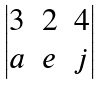<formula> <loc_0><loc_0><loc_500><loc_500>\begin{vmatrix} 3 & 2 & 4 \\ a & e & j \end{vmatrix}</formula> 